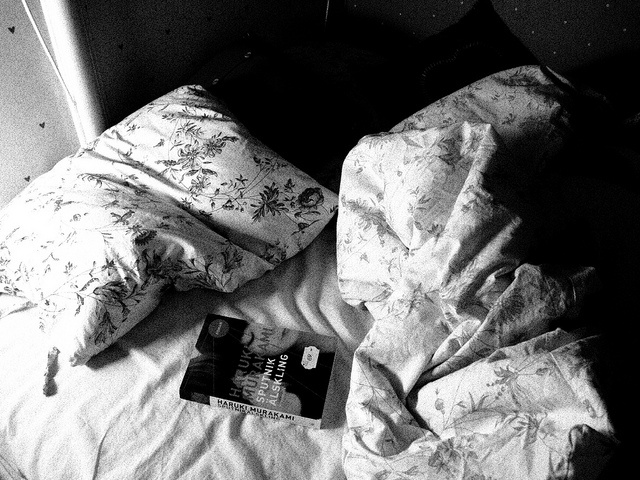Describe the objects in this image and their specific colors. I can see bed in darkgray, lightgray, black, and gray tones and book in darkgray, black, gray, and lightgray tones in this image. 